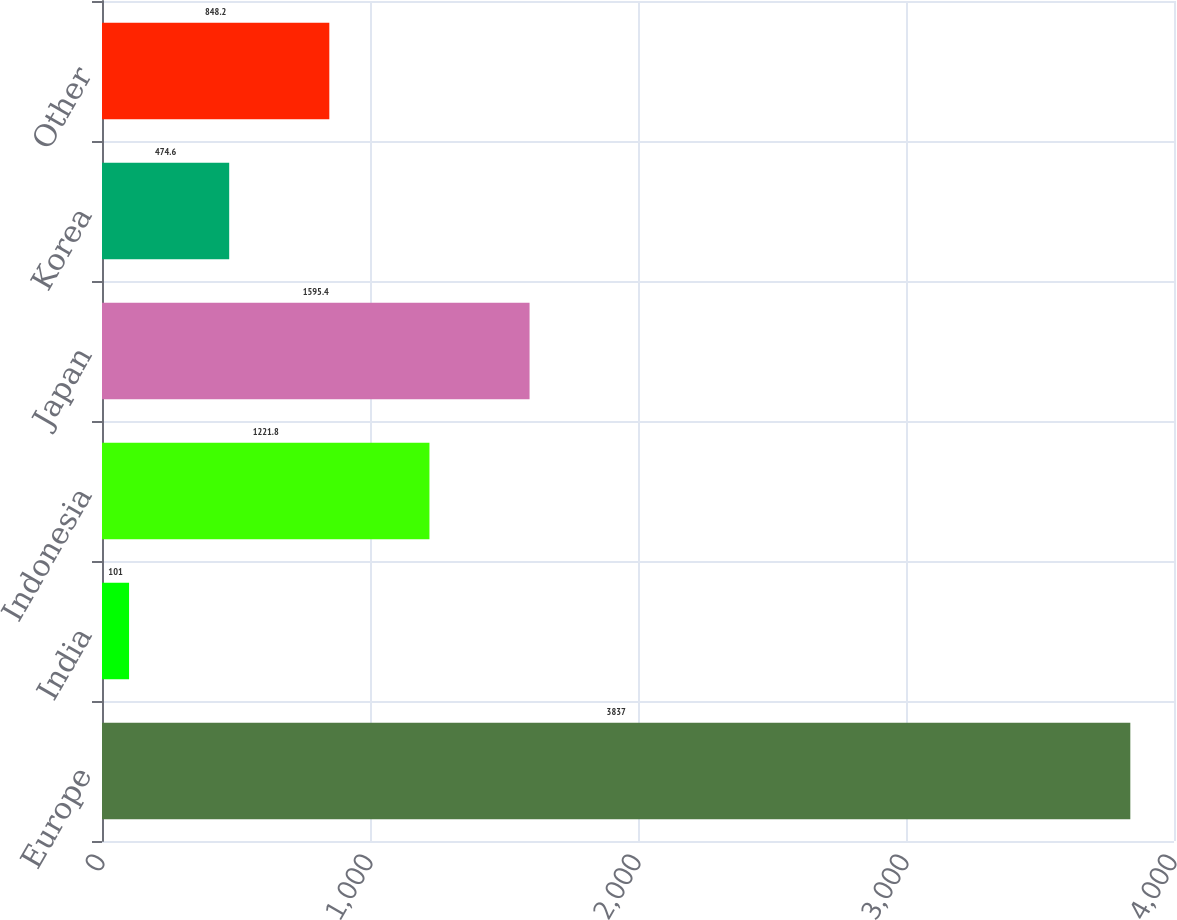Convert chart to OTSL. <chart><loc_0><loc_0><loc_500><loc_500><bar_chart><fcel>Europe<fcel>India<fcel>Indonesia<fcel>Japan<fcel>Korea<fcel>Other<nl><fcel>3837<fcel>101<fcel>1221.8<fcel>1595.4<fcel>474.6<fcel>848.2<nl></chart> 